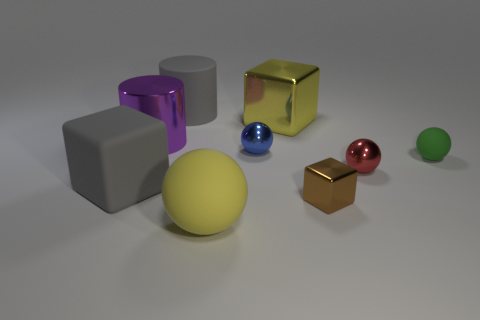Subtract all red metal balls. How many balls are left? 3 Add 1 small metallic balls. How many objects exist? 10 Subtract all yellow balls. How many balls are left? 3 Subtract all cylinders. How many objects are left? 7 Subtract 3 spheres. How many spheres are left? 1 Subtract 1 gray cubes. How many objects are left? 8 Subtract all gray blocks. Subtract all purple spheres. How many blocks are left? 2 Subtract all tiny green things. Subtract all tiny metallic spheres. How many objects are left? 6 Add 9 rubber cubes. How many rubber cubes are left? 10 Add 4 small shiny blocks. How many small shiny blocks exist? 5 